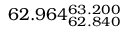<formula> <loc_0><loc_0><loc_500><loc_500>6 2 . 9 6 4 _ { 6 2 . 8 4 0 } ^ { 6 3 . 2 0 0 }</formula> 